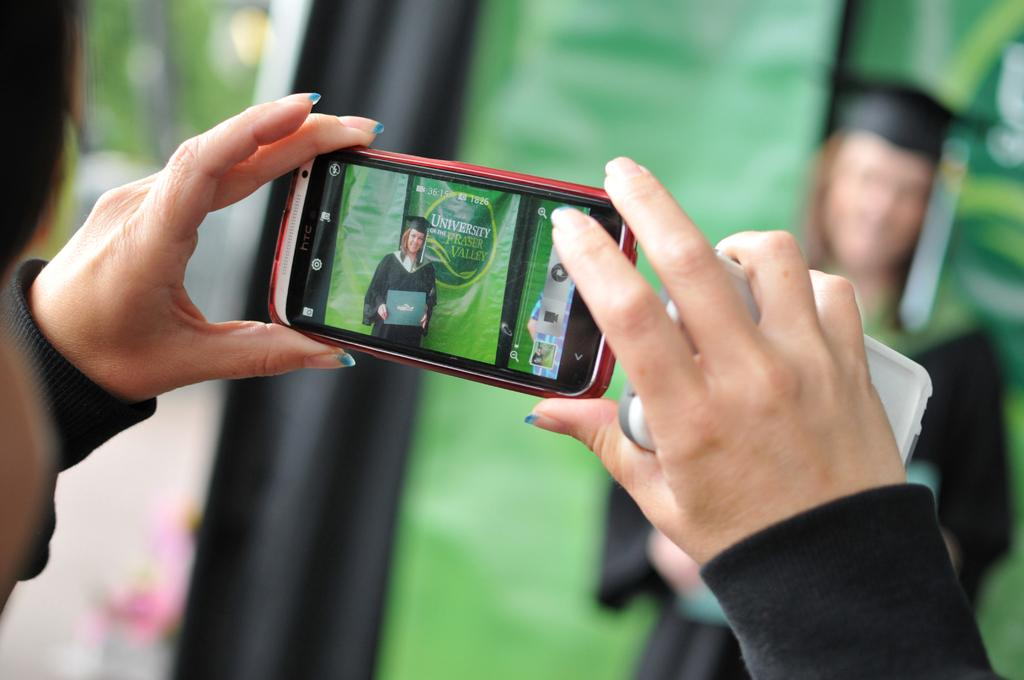<image>
Offer a succinct explanation of the picture presented. Someone takes a picture of another person in a graduate gown with an HTC phone. 